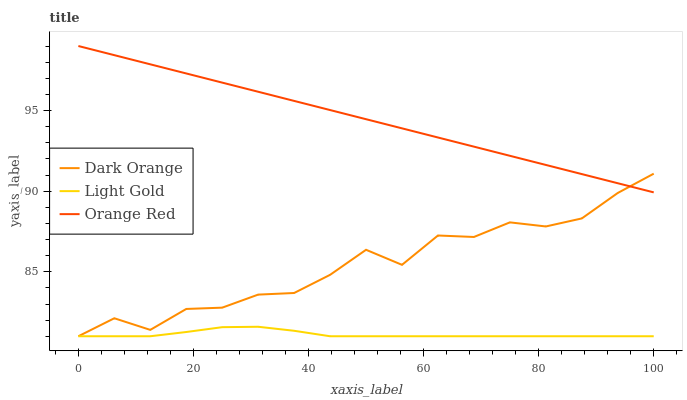Does Orange Red have the minimum area under the curve?
Answer yes or no. No. Does Light Gold have the maximum area under the curve?
Answer yes or no. No. Is Light Gold the smoothest?
Answer yes or no. No. Is Light Gold the roughest?
Answer yes or no. No. Does Orange Red have the lowest value?
Answer yes or no. No. Does Light Gold have the highest value?
Answer yes or no. No. Is Light Gold less than Orange Red?
Answer yes or no. Yes. Is Orange Red greater than Light Gold?
Answer yes or no. Yes. Does Light Gold intersect Orange Red?
Answer yes or no. No. 